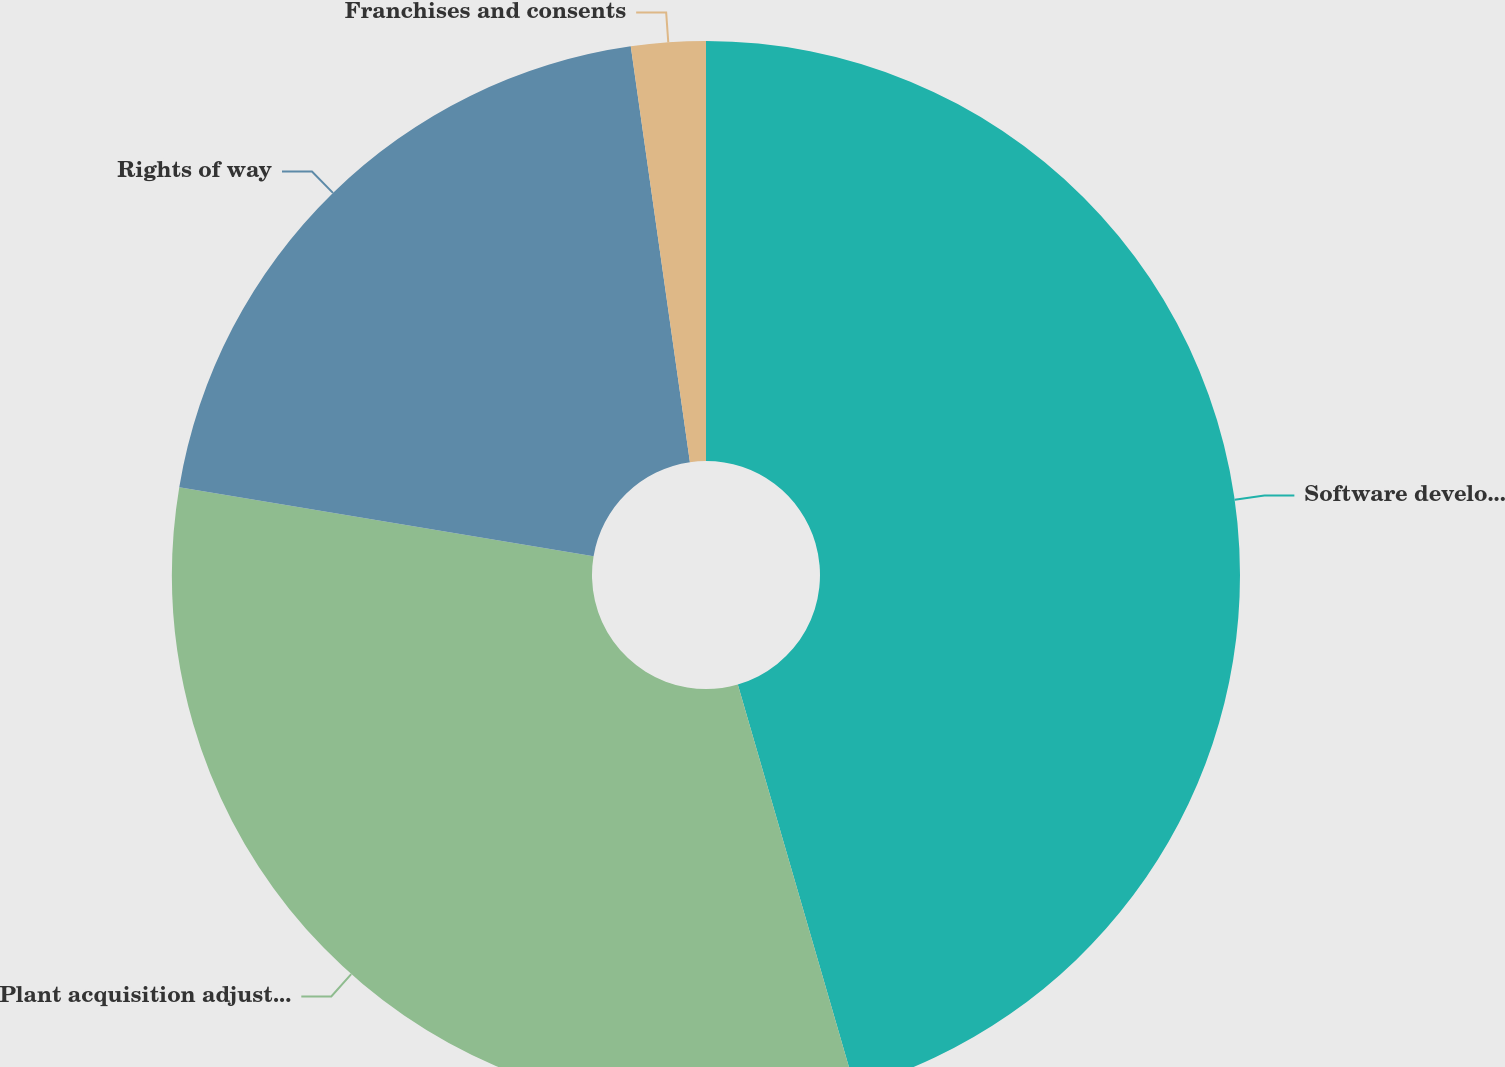Convert chart. <chart><loc_0><loc_0><loc_500><loc_500><pie_chart><fcel>Software development<fcel>Plant acquisition adjustments<fcel>Rights of way<fcel>Franchises and consents<nl><fcel>45.5%<fcel>32.13%<fcel>20.12%<fcel>2.25%<nl></chart> 